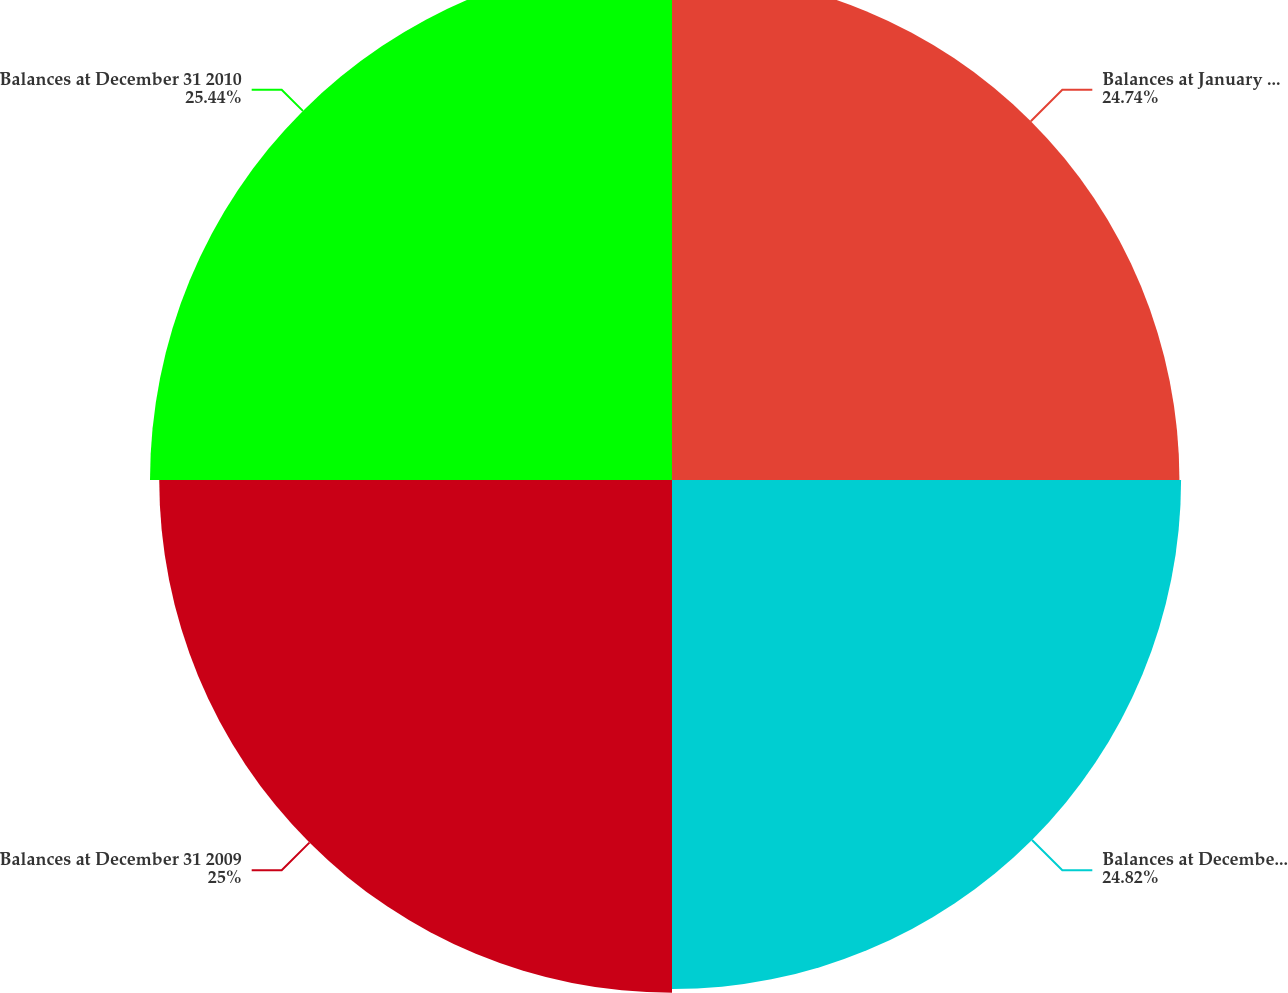Convert chart to OTSL. <chart><loc_0><loc_0><loc_500><loc_500><pie_chart><fcel>Balances at January 1 2008<fcel>Balances at December 31 2008<fcel>Balances at December 31 2009<fcel>Balances at December 31 2010<nl><fcel>24.74%<fcel>24.82%<fcel>25.0%<fcel>25.45%<nl></chart> 